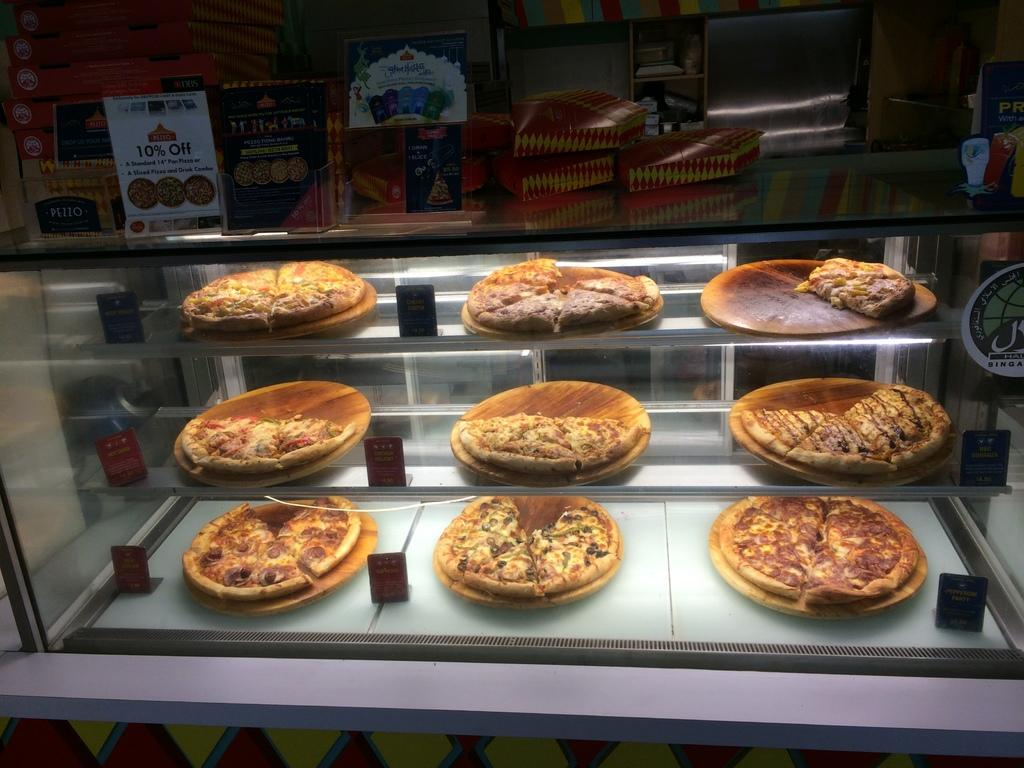What type of food can be seen in the image? There are pizzas on wooden-pans in the image. How are the wooden-pans arranged in the image? The wooden-pans are on glass racks in the image. What is placed on top of the glass racks? There are cardboard boxes on top in the image. What type of material is visible in the image? There are boards visible in the image. Can you describe the surrounding environment in the image? There are other objects around in the image. Are there any bones visible in the image? There are no bones present in the image. What type of plants can be seen growing around the pizzas in the image? There are no plants visible in the image. 